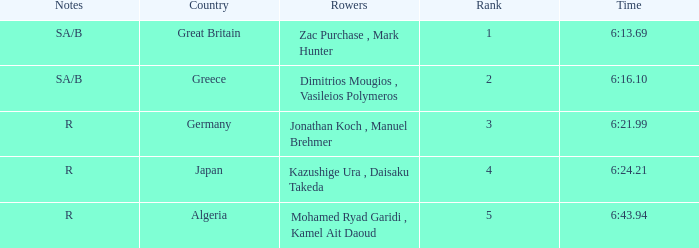What are the notes with the time 6:24.21? R. 